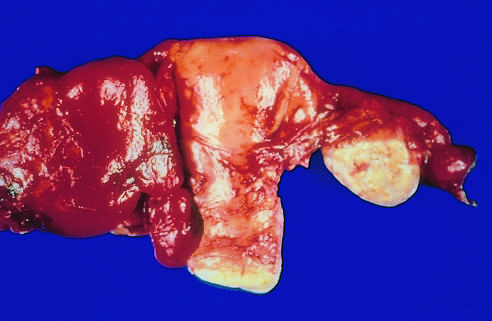s the kidney adherent to the adjacent ovary on the other side?
Answer the question using a single word or phrase. No 